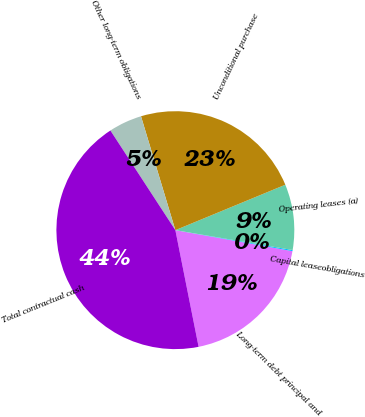Convert chart to OTSL. <chart><loc_0><loc_0><loc_500><loc_500><pie_chart><fcel>Long-term debt principal and<fcel>Capital leaseobligations<fcel>Operating leases (a)<fcel>Unconditional purchase<fcel>Other long-term obligations<fcel>Total contractual cash<nl><fcel>19.05%<fcel>0.15%<fcel>8.91%<fcel>23.43%<fcel>4.53%<fcel>43.94%<nl></chart> 